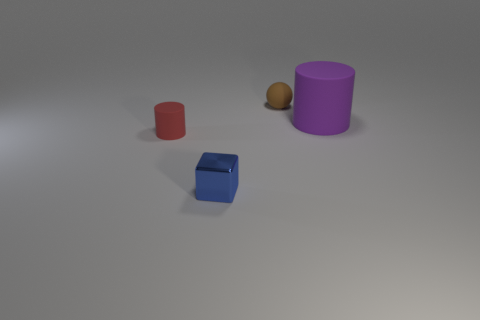How big is the rubber cylinder that is left of the small rubber object that is on the right side of the thing that is left of the blue metallic object?
Keep it short and to the point. Small. What number of cubes are the same material as the small ball?
Offer a very short reply. 0. How many cyan matte balls have the same size as the blue metal block?
Give a very brief answer. 0. What material is the cylinder left of the matte cylinder that is on the right side of the tiny rubber object on the left side of the metal thing made of?
Provide a succinct answer. Rubber. What number of objects are either small rubber things or purple rubber cylinders?
Give a very brief answer. 3. Is there anything else that is made of the same material as the blue block?
Ensure brevity in your answer.  No. There is a blue thing; what shape is it?
Your answer should be very brief. Cube. There is a purple thing that is on the right side of the tiny thing that is behind the small rubber cylinder; what shape is it?
Your answer should be very brief. Cylinder. Is the material of the cylinder that is behind the small red cylinder the same as the cube?
Ensure brevity in your answer.  No. How many gray things are large rubber things or small matte balls?
Offer a very short reply. 0. 